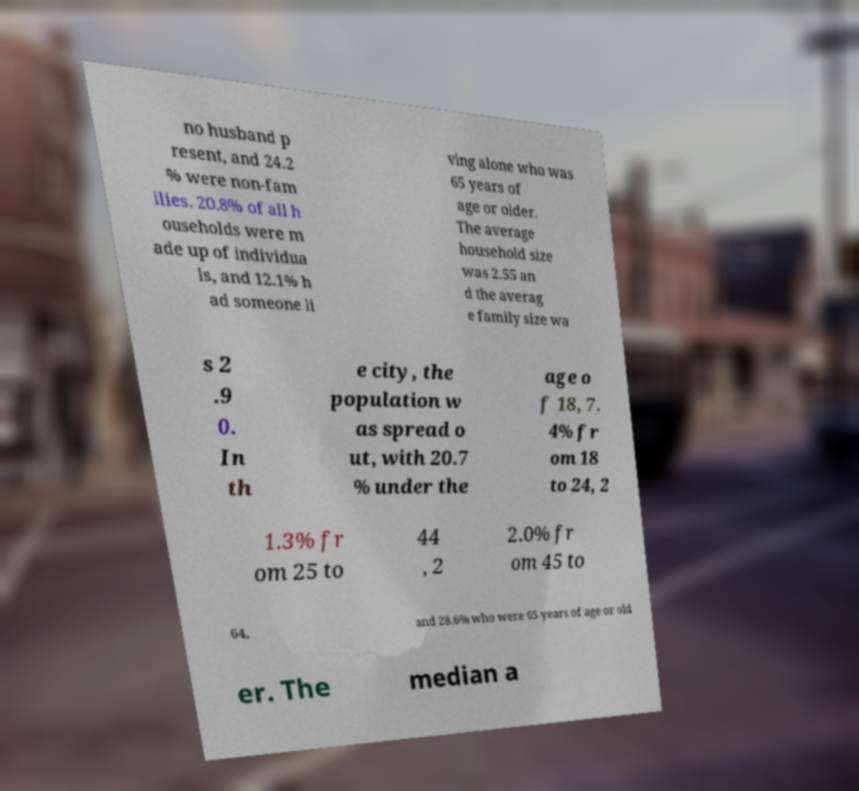For documentation purposes, I need the text within this image transcribed. Could you provide that? no husband p resent, and 24.2 % were non-fam ilies. 20.8% of all h ouseholds were m ade up of individua ls, and 12.1% h ad someone li ving alone who was 65 years of age or older. The average household size was 2.55 an d the averag e family size wa s 2 .9 0. In th e city, the population w as spread o ut, with 20.7 % under the age o f 18, 7. 4% fr om 18 to 24, 2 1.3% fr om 25 to 44 , 2 2.0% fr om 45 to 64, and 28.6% who were 65 years of age or old er. The median a 